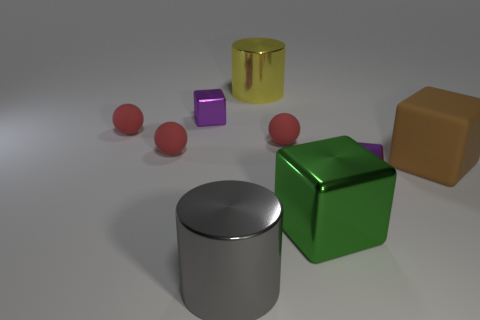There is a thing that is on the left side of the brown rubber block and on the right side of the big metallic cube; what is its shape?
Keep it short and to the point. Cube. What number of tiny objects have the same color as the rubber block?
Make the answer very short. 0. How many objects are purple metal things in front of the big matte object or small shiny blocks that are in front of the matte block?
Your response must be concise. 1. There is a gray metallic object that is the same size as the rubber block; what is its shape?
Offer a very short reply. Cylinder. What is the size of the yellow thing that is the same material as the big green block?
Offer a terse response. Large. Is the green object the same shape as the big yellow object?
Offer a very short reply. No. There is a block that is the same size as the brown object; what is its color?
Make the answer very short. Green. What size is the yellow shiny thing that is the same shape as the big gray object?
Ensure brevity in your answer.  Large. There is a tiny purple shiny thing that is right of the large yellow metal object; what is its shape?
Provide a short and direct response. Cube. Is the shape of the large gray thing the same as the big yellow object that is to the right of the big gray cylinder?
Your response must be concise. Yes. 